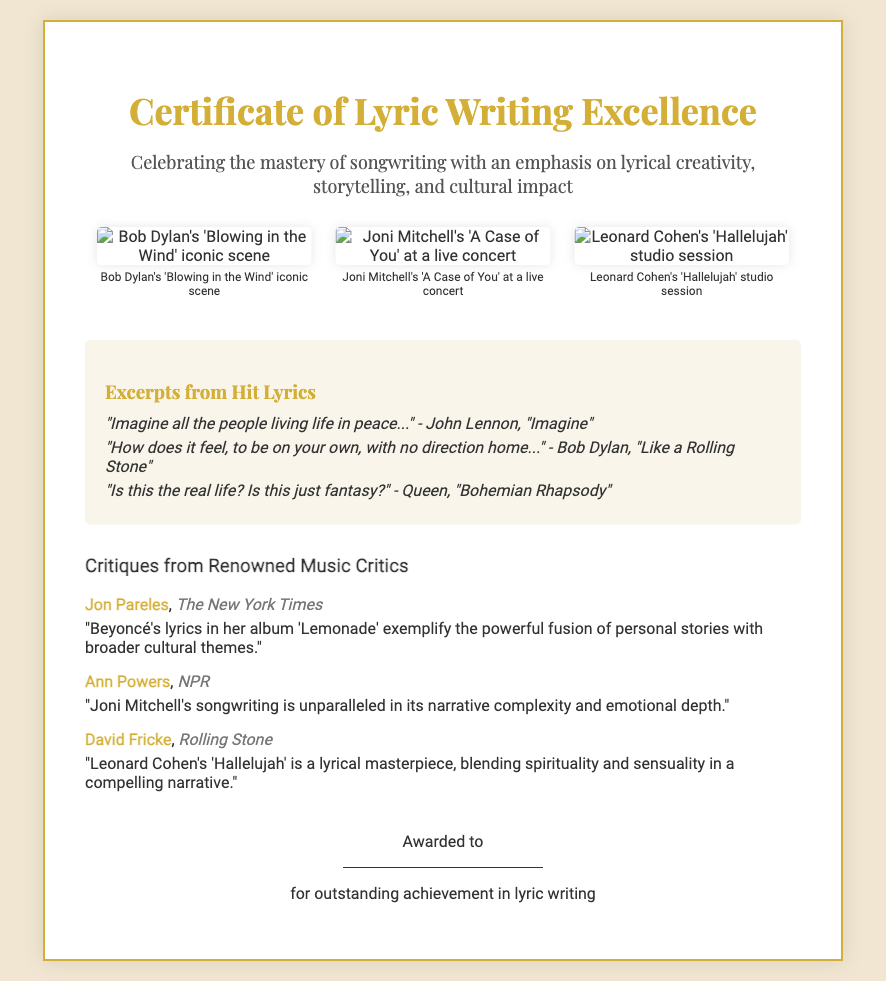What is the title of the certificate? The title of the certificate is prominently displayed at the top of the document.
Answer: Certificate of Lyric Writing Excellence Who is one of the critics mentioned in the document? The document lists critiques from renowned music critics and includes specific names.
Answer: Jon Pareles What is highlighted in the section titled "Excerpts from Hit Lyrics"? This section features specific lines from popular songs.
Answer: Hit lyrics How many hand-drawn illustrations are included? The document displays a total of three illustrations related to iconic song scenes.
Answer: Three What color is used for the certificate's border? The document specifies the color of the border surrounding the certificate.
Answer: Gold Which song's lyrics are cited by Bob Dylan? The excerpt of a famous song by Bob Dylan is provided in the lyrics section.
Answer: Like a Rolling Stone What cultural aspect is emphasized in the certificate's description? The wording in the description stresses a certain theme related to songwriting.
Answer: Cultural impact Which singer-songwriter's narrative complexity is noted in the critiques? The document features a critique referencing a specific artist's songwriting style.
Answer: Joni Mitchell 